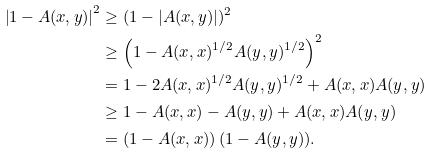<formula> <loc_0><loc_0><loc_500><loc_500>\left | 1 - A ( x , y ) \right | ^ { 2 } & \geq ( 1 - \left | A ( x , y ) \right | ) ^ { 2 } \\ & \geq \left ( 1 - A ( x , x ) ^ { 1 / 2 } A ( y , y ) ^ { 1 / 2 } \right ) ^ { 2 } \\ & = 1 - 2 A ( x , x ) ^ { 1 / 2 } A ( y , y ) ^ { 1 / 2 } + A ( x , x ) A ( y , y ) \\ & \geq 1 - A ( x , x ) - A ( y , y ) + A ( x , x ) A ( y , y ) \\ & = \left ( 1 - A ( x , x ) \right ) \left ( 1 - A ( y , y \right ) ) .</formula> 